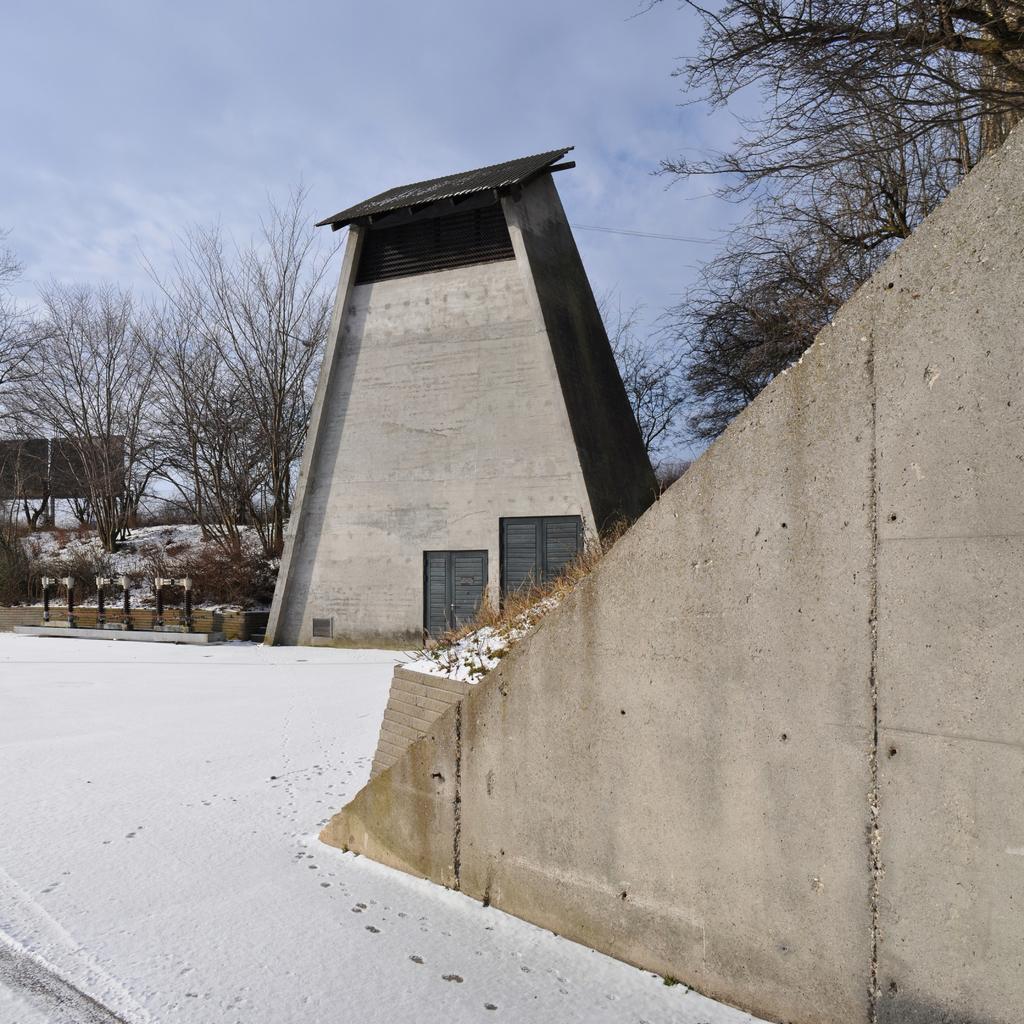Please provide a concise description of this image. In this image we can see the wall here, snow on the road, an architecture building, trees, board and sky with clouds in the background. 